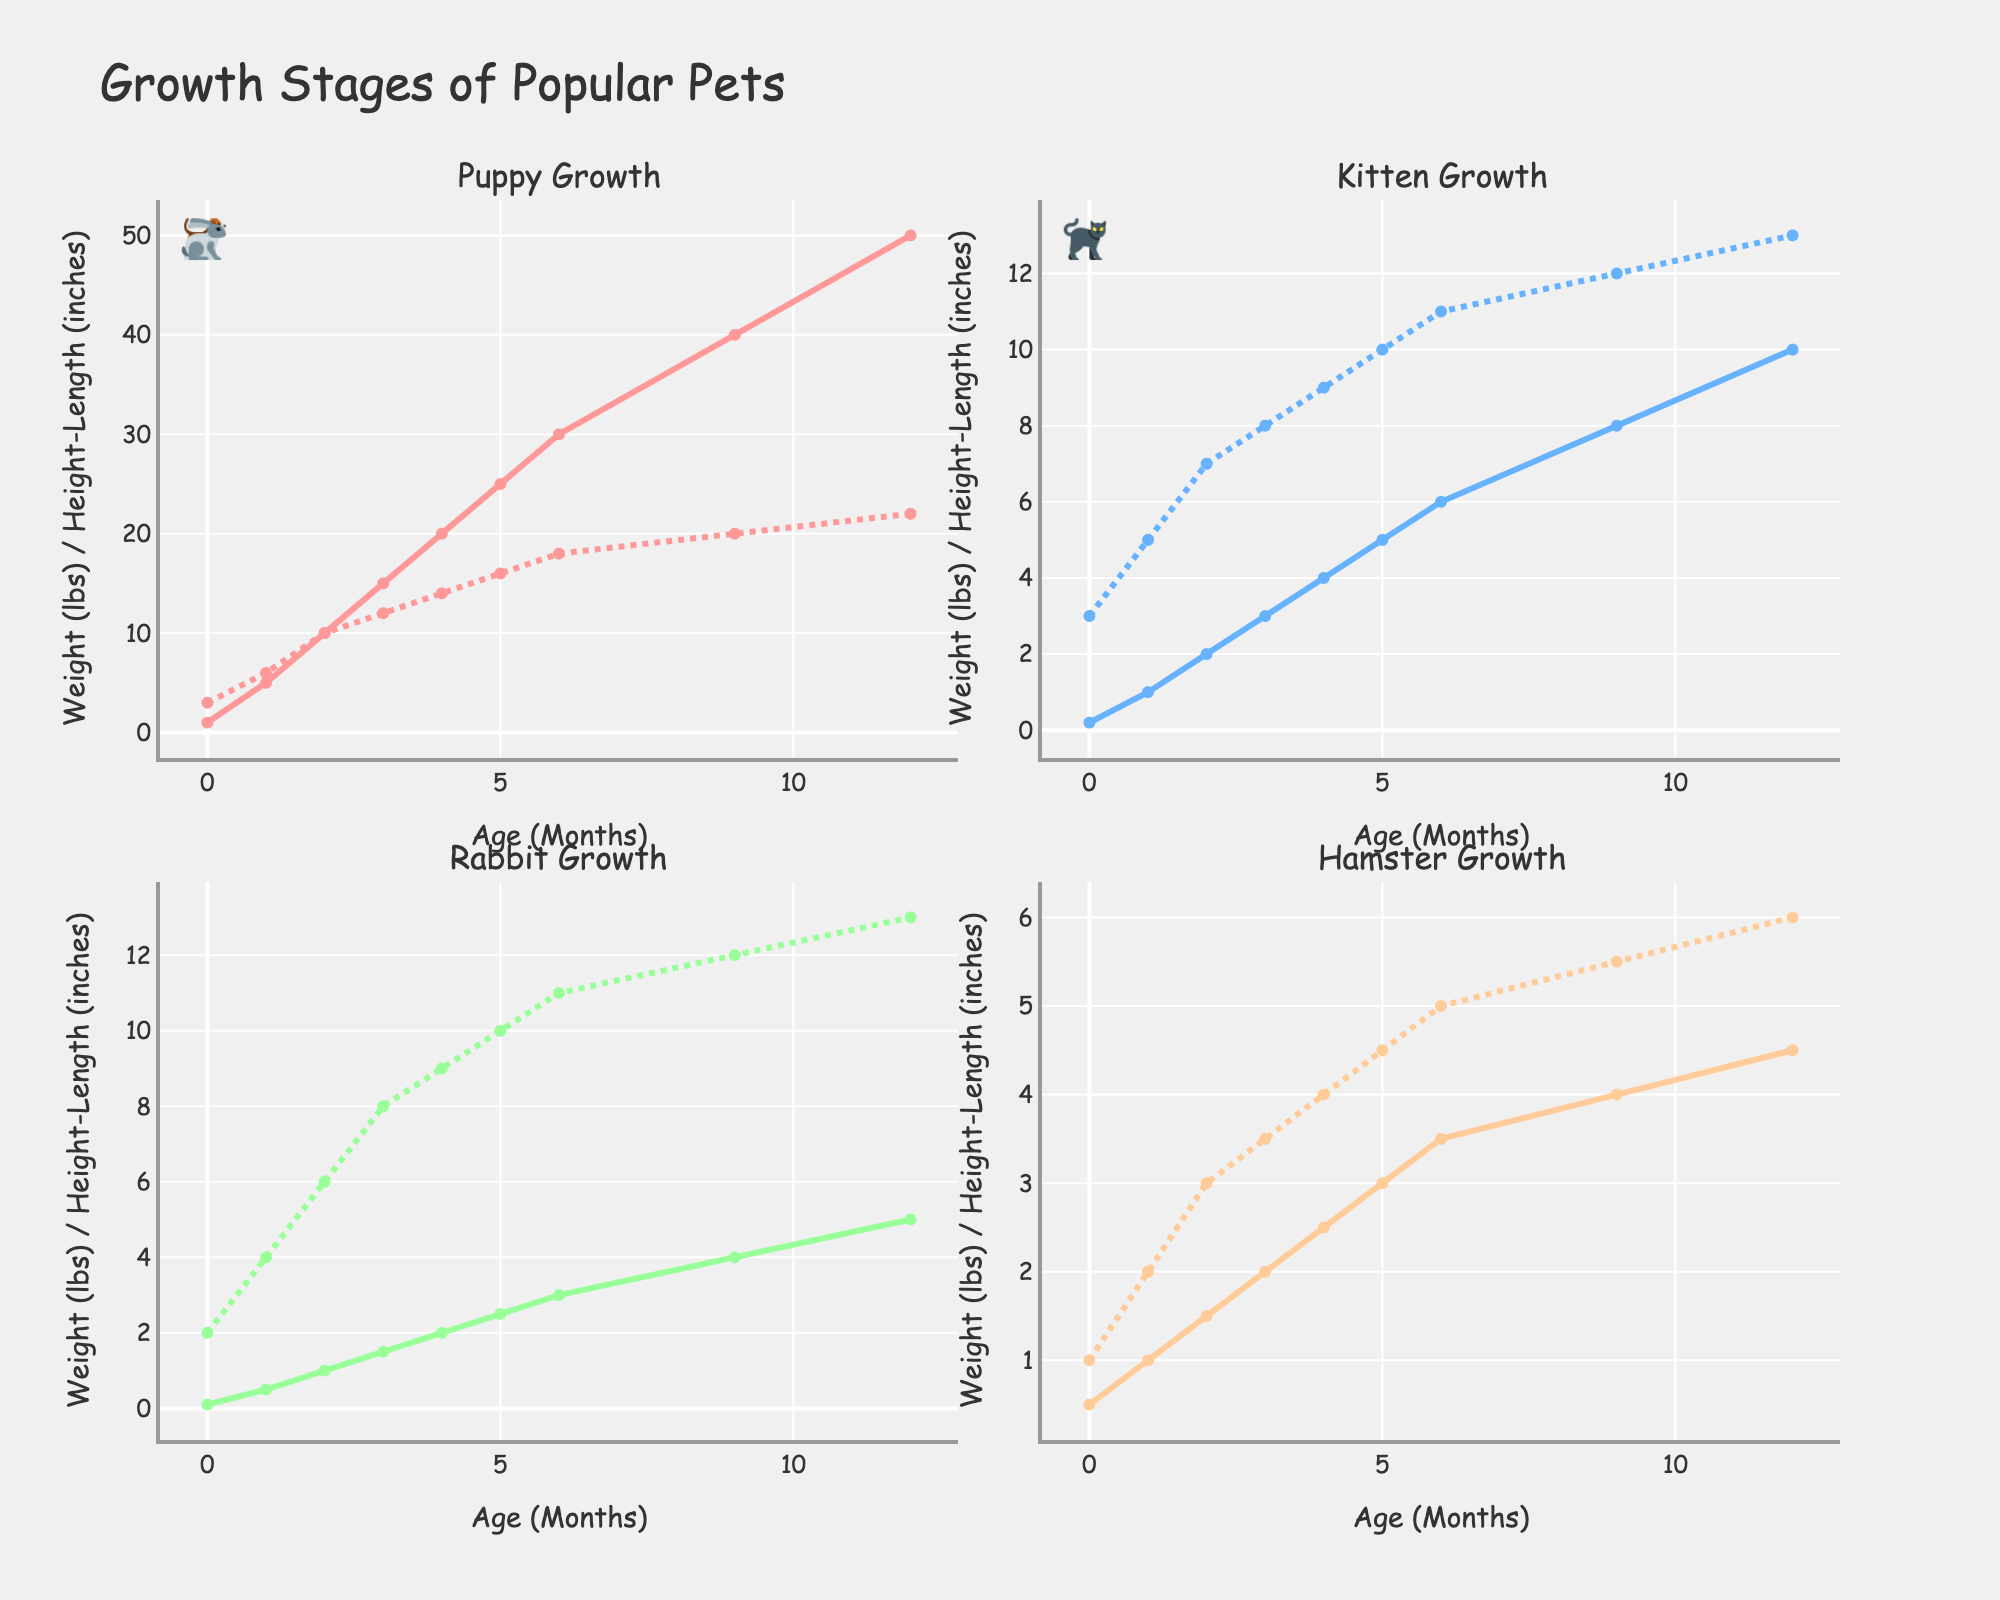What's the title of the figure? The title is located at the top-center of the figure and is typically a few words summarizing the main point of the visualization. Here, it is clearly written as "Speaker Sales Trends (2018-2022)."
Answer: Speaker Sales Trends (2018-2022) How many different speaker types are shown in the figure? The figure has three subplots, each representing a different speaker type. The subplot titles are "Bookshelf," "Floor-standing," and "Portable."
Answer: 3 What is the trend in sales for Portable speakers over the years? By observing the lines in the subplot for Portable speakers, the sales show a consistent upward trend from 2018 to 2022. The y-values increase each year from 22,000 to 40,000.
Answer: An increasing trend Which year had the highest sales for Floor-standing speakers? Look at the y-values for Floor-standing speakers across all years. 2018 had the highest value at 12,000, with values decreasing each year afterwards.
Answer: 2018 What is the average sales figure for Bookshelf speakers over the 5 years? Add up the sales figures for Bookshelf speakers over the years (15000, 16500, 18000, 19500, 21000), then divide by 5. (15000 + 16500 + 18000 + 19500 + 21000) / 5 = 18000
Answer: 18000 Which speaker type had the most consistent sales trend? Consistency can be judged by the slope and smoothness of the trend line. Bookshelf and Portable show consistent upward trends, whereas Floor-standing shows a decline. Similarly increasing year-on-year data in Bookshelf and Portable suggests they are the most consistent.
Answer: Bookshelf or Portable What is the difference in sales between Bookshelf and Portable speakers in 2020? Identify the sales values for both types in 2020: Bookshelf (18,000) and Portable (30,000). Subtract the smaller value from the larger one: 30,000 - 18,000 = 12,000.
Answer: 12,000 How do Bookshelf speaker sales in 2021 compare to Floor-standing speaker sales in the same year? Look at the sales values for both in 2021: Bookshelf (19,500) and Floor-standing (9,500). Bookshelf sales are higher than Floor-standing sales.
Answer: Bookshelf sales are higher In which year did Portable speakers surpass 30,000 units in sales? Locate the sales values for Portable speakers. Sales surpassed 30,000 in 2020 when the sales reached 30,000 units.
Answer: 2020 What is the combined total sales of all speakers in 2022? Sum the sales values for the three speaker types in 2022: Bookshelf (21,000), Floor-standing (9,000), and Portable (40,000). 21,000 + 9,000 + 40,000 = 70,000.
Answer: 70,000 